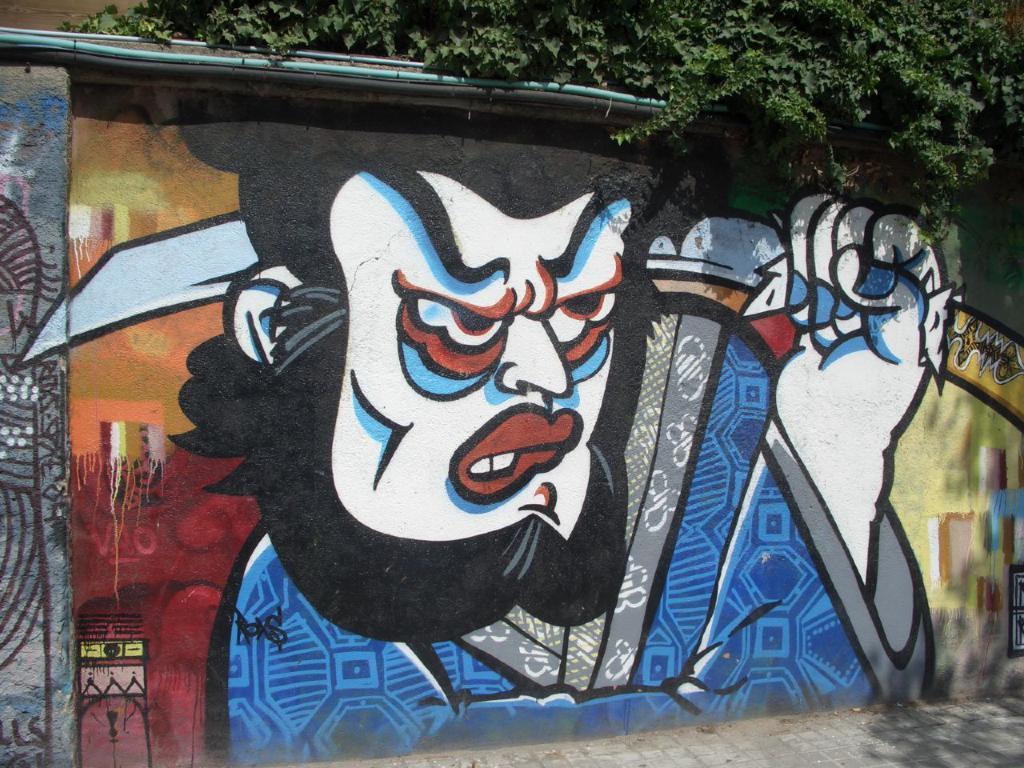Please provide a concise description of this image. In the image we can see a wall. On the wall there is a painting, this is a footpath and a tree. 